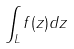Convert formula to latex. <formula><loc_0><loc_0><loc_500><loc_500>\int _ { L } f ( z ) d z</formula> 